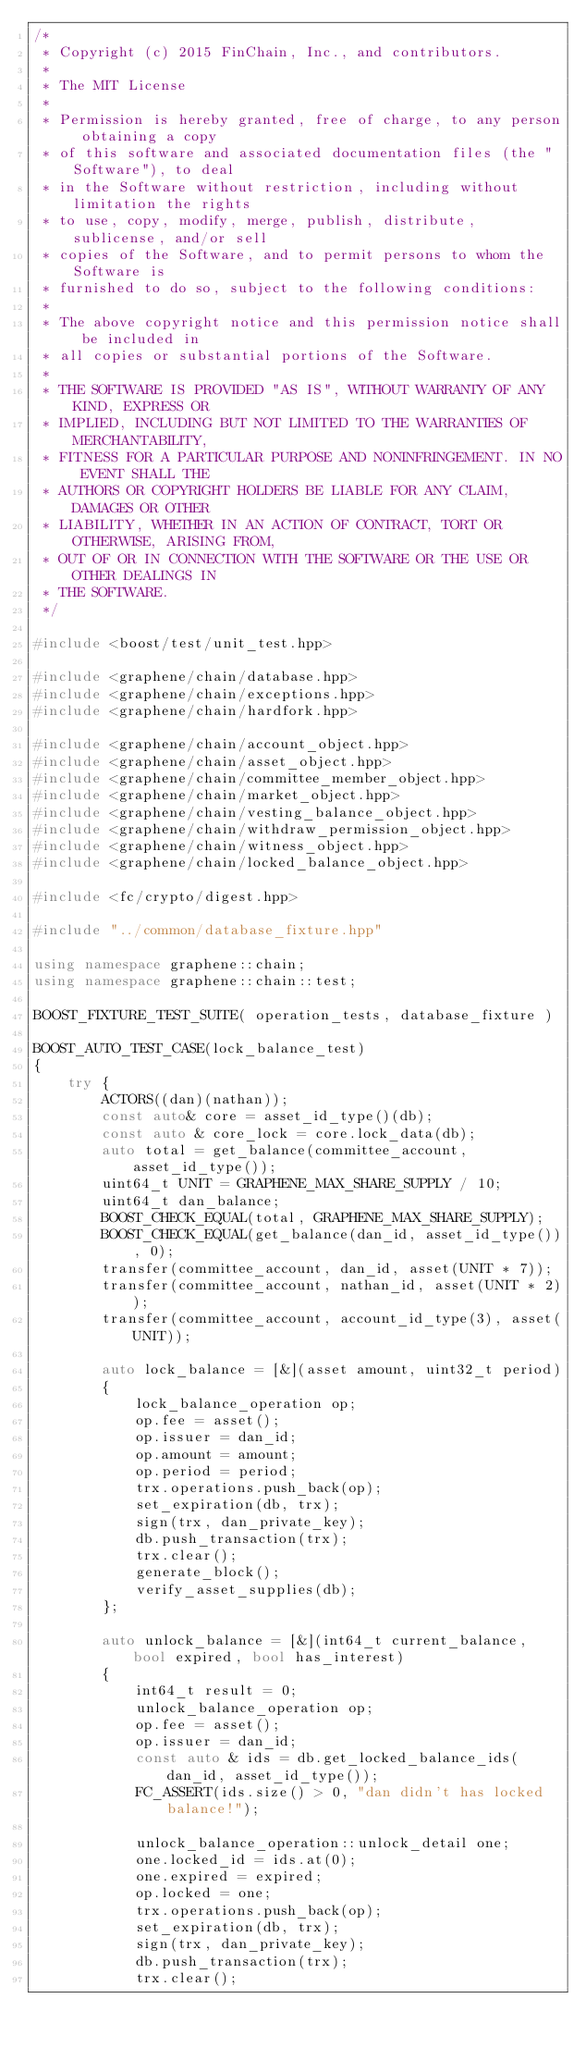Convert code to text. <code><loc_0><loc_0><loc_500><loc_500><_C++_>/*
 * Copyright (c) 2015 FinChain, Inc., and contributors.
 *
 * The MIT License
 *
 * Permission is hereby granted, free of charge, to any person obtaining a copy
 * of this software and associated documentation files (the "Software"), to deal
 * in the Software without restriction, including without limitation the rights
 * to use, copy, modify, merge, publish, distribute, sublicense, and/or sell
 * copies of the Software, and to permit persons to whom the Software is
 * furnished to do so, subject to the following conditions:
 *
 * The above copyright notice and this permission notice shall be included in
 * all copies or substantial portions of the Software.
 *
 * THE SOFTWARE IS PROVIDED "AS IS", WITHOUT WARRANTY OF ANY KIND, EXPRESS OR
 * IMPLIED, INCLUDING BUT NOT LIMITED TO THE WARRANTIES OF MERCHANTABILITY,
 * FITNESS FOR A PARTICULAR PURPOSE AND NONINFRINGEMENT. IN NO EVENT SHALL THE
 * AUTHORS OR COPYRIGHT HOLDERS BE LIABLE FOR ANY CLAIM, DAMAGES OR OTHER
 * LIABILITY, WHETHER IN AN ACTION OF CONTRACT, TORT OR OTHERWISE, ARISING FROM,
 * OUT OF OR IN CONNECTION WITH THE SOFTWARE OR THE USE OR OTHER DEALINGS IN
 * THE SOFTWARE.
 */

#include <boost/test/unit_test.hpp>

#include <graphene/chain/database.hpp>
#include <graphene/chain/exceptions.hpp>
#include <graphene/chain/hardfork.hpp>

#include <graphene/chain/account_object.hpp>
#include <graphene/chain/asset_object.hpp>
#include <graphene/chain/committee_member_object.hpp>
#include <graphene/chain/market_object.hpp>
#include <graphene/chain/vesting_balance_object.hpp>
#include <graphene/chain/withdraw_permission_object.hpp>
#include <graphene/chain/witness_object.hpp>
#include <graphene/chain/locked_balance_object.hpp>

#include <fc/crypto/digest.hpp>

#include "../common/database_fixture.hpp"

using namespace graphene::chain;
using namespace graphene::chain::test;

BOOST_FIXTURE_TEST_SUITE( operation_tests, database_fixture )

BOOST_AUTO_TEST_CASE(lock_balance_test)
{
	try {
		ACTORS((dan)(nathan));
		const auto& core = asset_id_type()(db);
		const auto & core_lock = core.lock_data(db);
		auto total = get_balance(committee_account, asset_id_type());
		uint64_t UNIT = GRAPHENE_MAX_SHARE_SUPPLY / 10;
		uint64_t dan_balance;
		BOOST_CHECK_EQUAL(total, GRAPHENE_MAX_SHARE_SUPPLY);
		BOOST_CHECK_EQUAL(get_balance(dan_id, asset_id_type()), 0);
		transfer(committee_account, dan_id, asset(UNIT * 7));
		transfer(committee_account, nathan_id, asset(UNIT * 2));
		transfer(committee_account, account_id_type(3), asset(UNIT));

		auto lock_balance = [&](asset amount, uint32_t period)
		{
			lock_balance_operation op;
			op.fee = asset();
			op.issuer = dan_id;
			op.amount = amount;
			op.period = period;
			trx.operations.push_back(op);
			set_expiration(db, trx);
			sign(trx, dan_private_key);
			db.push_transaction(trx);
			trx.clear();
			generate_block();
			verify_asset_supplies(db);
		};

		auto unlock_balance = [&](int64_t current_balance, bool expired, bool has_interest)
		{
			int64_t result = 0;
			unlock_balance_operation op;
			op.fee = asset();
			op.issuer = dan_id;
			const auto & ids = db.get_locked_balance_ids(dan_id, asset_id_type());
			FC_ASSERT(ids.size() > 0, "dan didn't has locked balance!");

			unlock_balance_operation::unlock_detail one;
			one.locked_id = ids.at(0);
			one.expired = expired;
			op.locked = one;
			trx.operations.push_back(op);
			set_expiration(db, trx);
			sign(trx, dan_private_key);
			db.push_transaction(trx);
			trx.clear();
</code> 